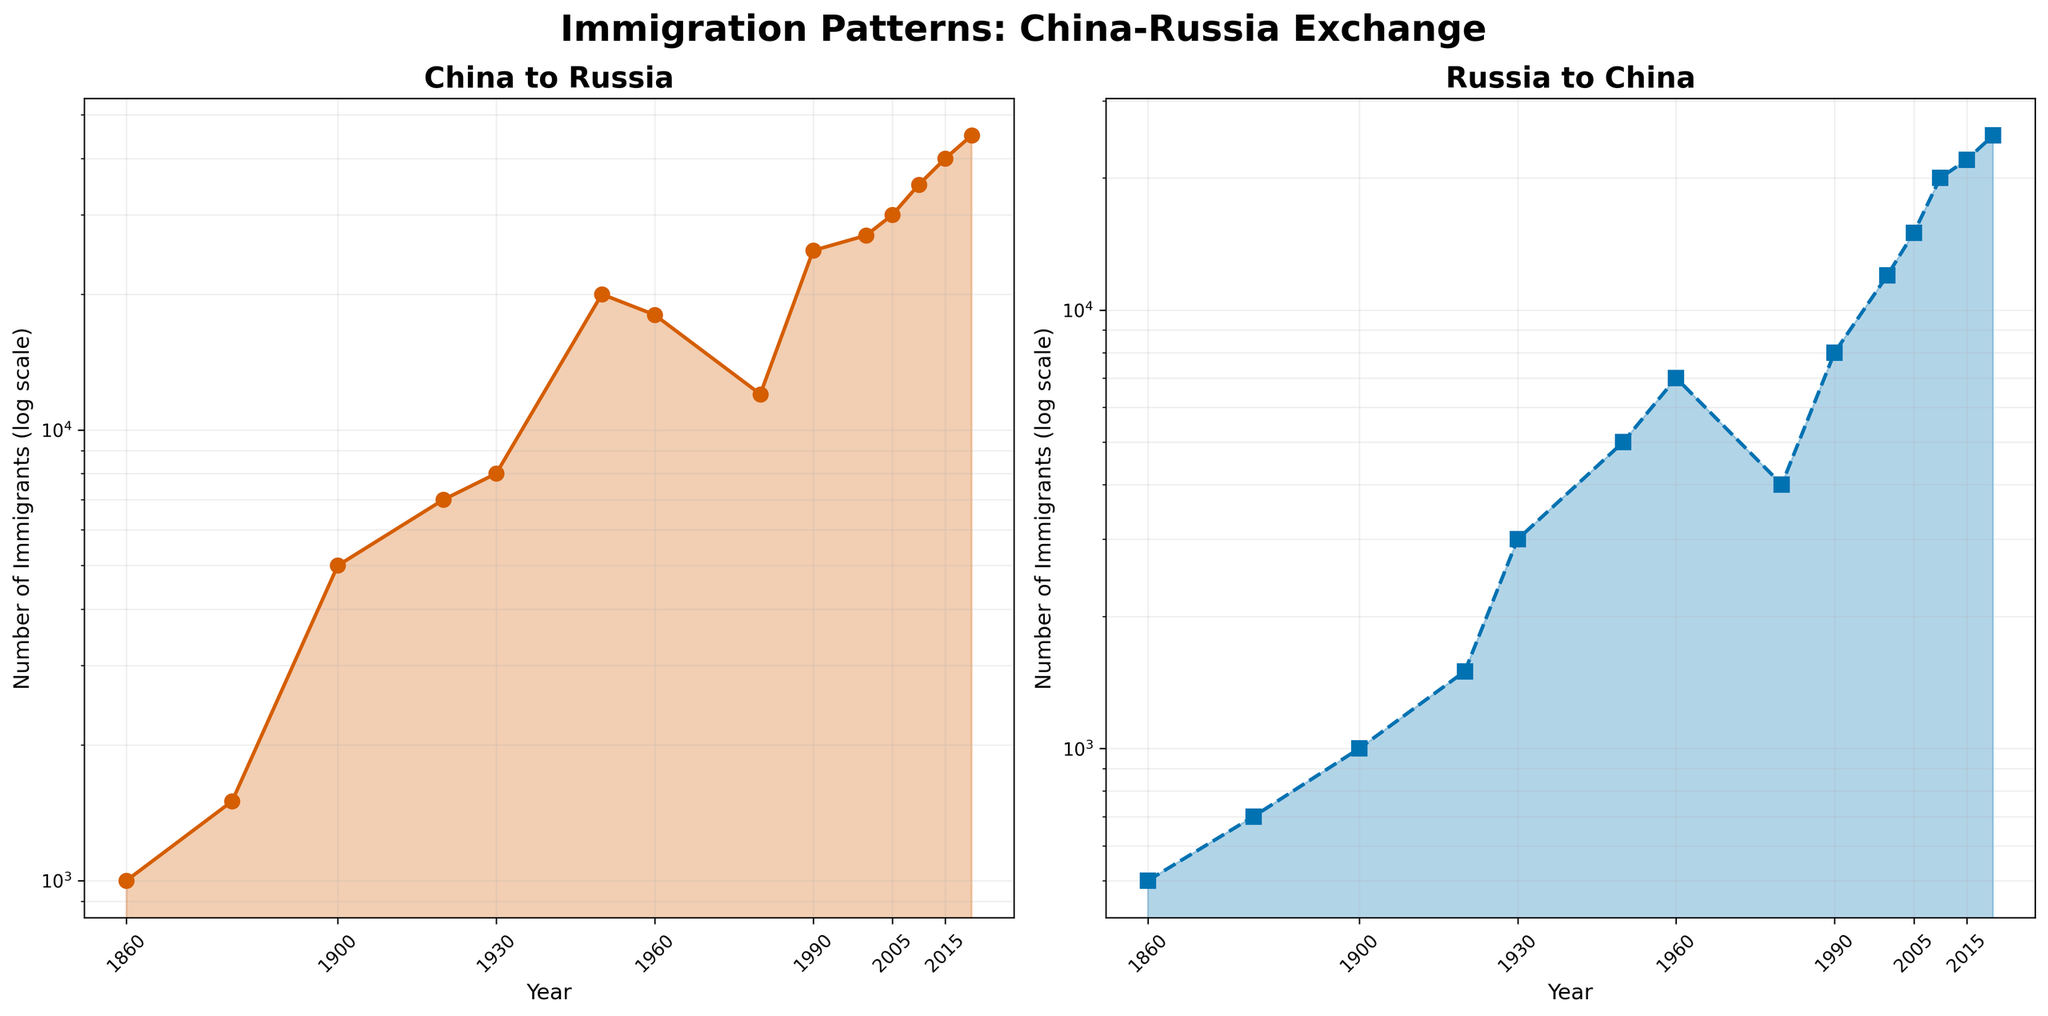What is the title of the entire figure? The title of the entire figure is displayed at the top of the figure in a larger font. It reads "Immigration Patterns: China-Russia Exchange".
Answer: Immigration Patterns: China-Russia Exchange Which subplot shows the data for immigrants from China to Russia? The subplot on the left-hand side, labeled "China to Russia", represents the data for immigrants from China to Russia.
Answer: The left subplot In which year does the number of immigrants from Russia to China first reach 10,000? The right subplot (Russia to China) shows that the number of immigrants from Russia to China first reaches 10,000 in the year 2000.
Answer: 2000 What is the approximate number of immigrants from China to Russia in 1960? Referring to the plot on the left, we can see that the number of immigrants from China to Russia in 1960 is around 18,000.
Answer: 18,000 How does the trend in immigration from China to Russia compare to the trend from Russia to China between 1860 and 2020? Both subplots (left for China to Russia and right for Russia to China) show an overall increasing trend. However, immigration from China to Russia starts lower and increases more steeply compared to the relatively steadier increase of immigration from Russia to China.
Answer: Steeper increase for China to Russia By how much did the number of immigrants from China to Russia increase between 1950 and 2010? In 1950, the number of immigrants from China to Russia was 20,000, and in 2010, it was 35,000. The increase is calculated as 35,000 - 20,000 = 15,000.
Answer: 15,000 What is the difference in the number of immigrants from Russia to China between the years 1920 and 2005? In 1920, the number of immigrants from Russia to China was 1,500, and in 2005, it was 15,000. The difference is calculated as 15,000 - 1,500 = 13,500.
Answer: 13,500 What was the ratio of immigrants from China to Russia in 2020 compared to 1860? In 2020, there were 45,000 immigrants from China to Russia, and in 1860, there were 1,000 immigrants. The ratio is calculated as 45,000 / 1,000 = 45.
Answer: 45 Between which years did the number of immigrants from China to Russia show the sharpest increase on the log scale? To evaluate the sharpest increase, we look at the steepest slope on the left subplot. This occurs between 1950 and 1960, where the number jumped from 20,000 to 18,000.
Answer: 1950 to 1960 What geometric feature highlights the fluctuations in the number of immigrants in each subplot? The filled area under each curve highlights the fluctuations in the number of immigrants over time. This feature visually emphasizes the changes and trends in the data.
Answer: Filled area under the curves 